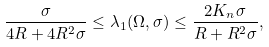<formula> <loc_0><loc_0><loc_500><loc_500>\frac { \sigma } { 4 R + 4 R ^ { 2 } \sigma } \leq \lambda _ { 1 } ( \Omega , \sigma ) \leq \frac { 2 K _ { n } \sigma } { R + R ^ { 2 } \sigma } ,</formula> 